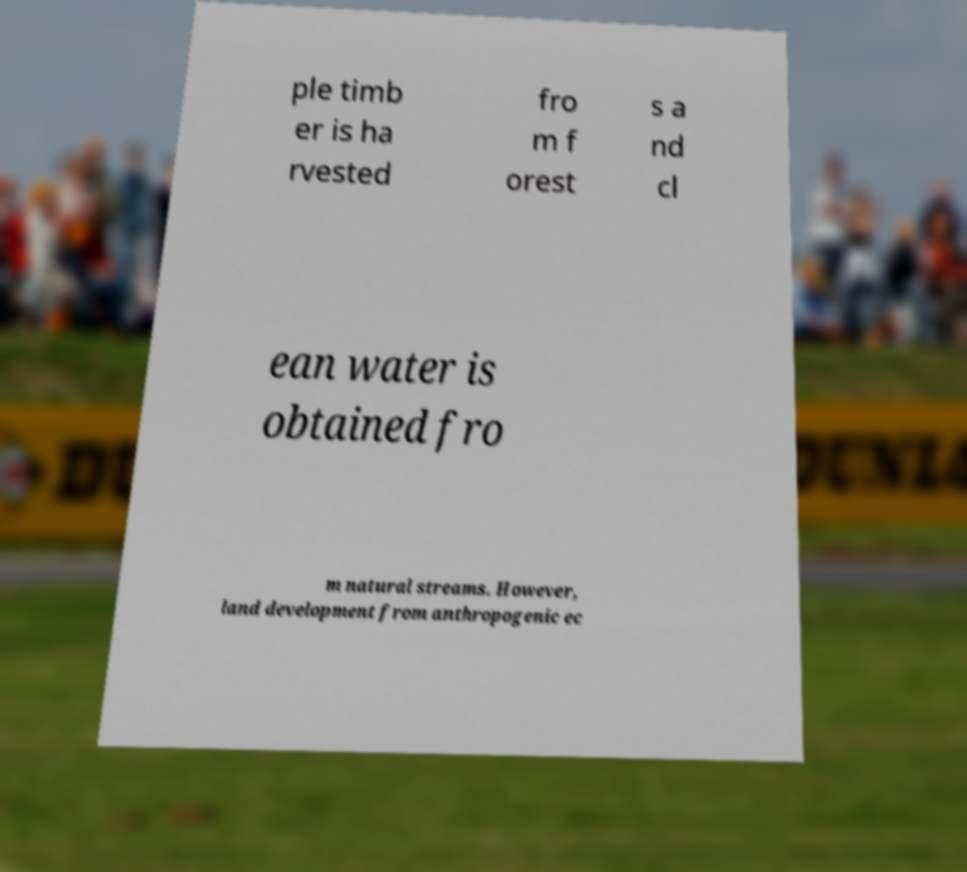There's text embedded in this image that I need extracted. Can you transcribe it verbatim? ple timb er is ha rvested fro m f orest s a nd cl ean water is obtained fro m natural streams. However, land development from anthropogenic ec 